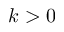Convert formula to latex. <formula><loc_0><loc_0><loc_500><loc_500>k > 0</formula> 